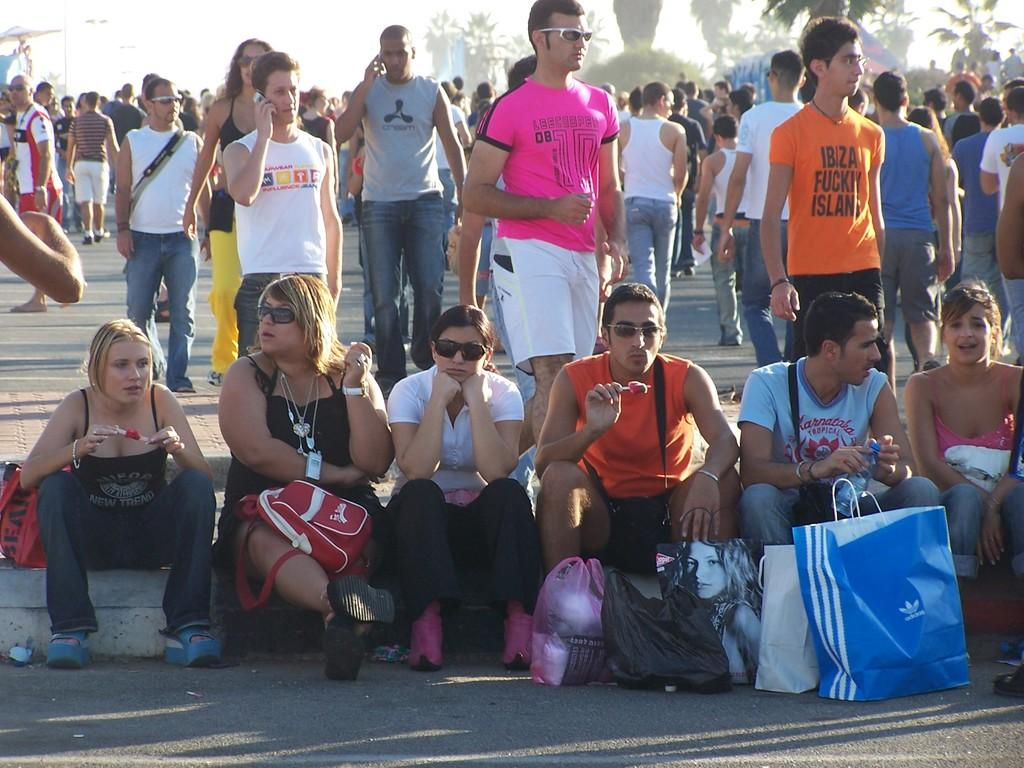Provide a one-sentence caption for the provided image. A large group of people sitting on a curb, one guy has an Adidas bag. 